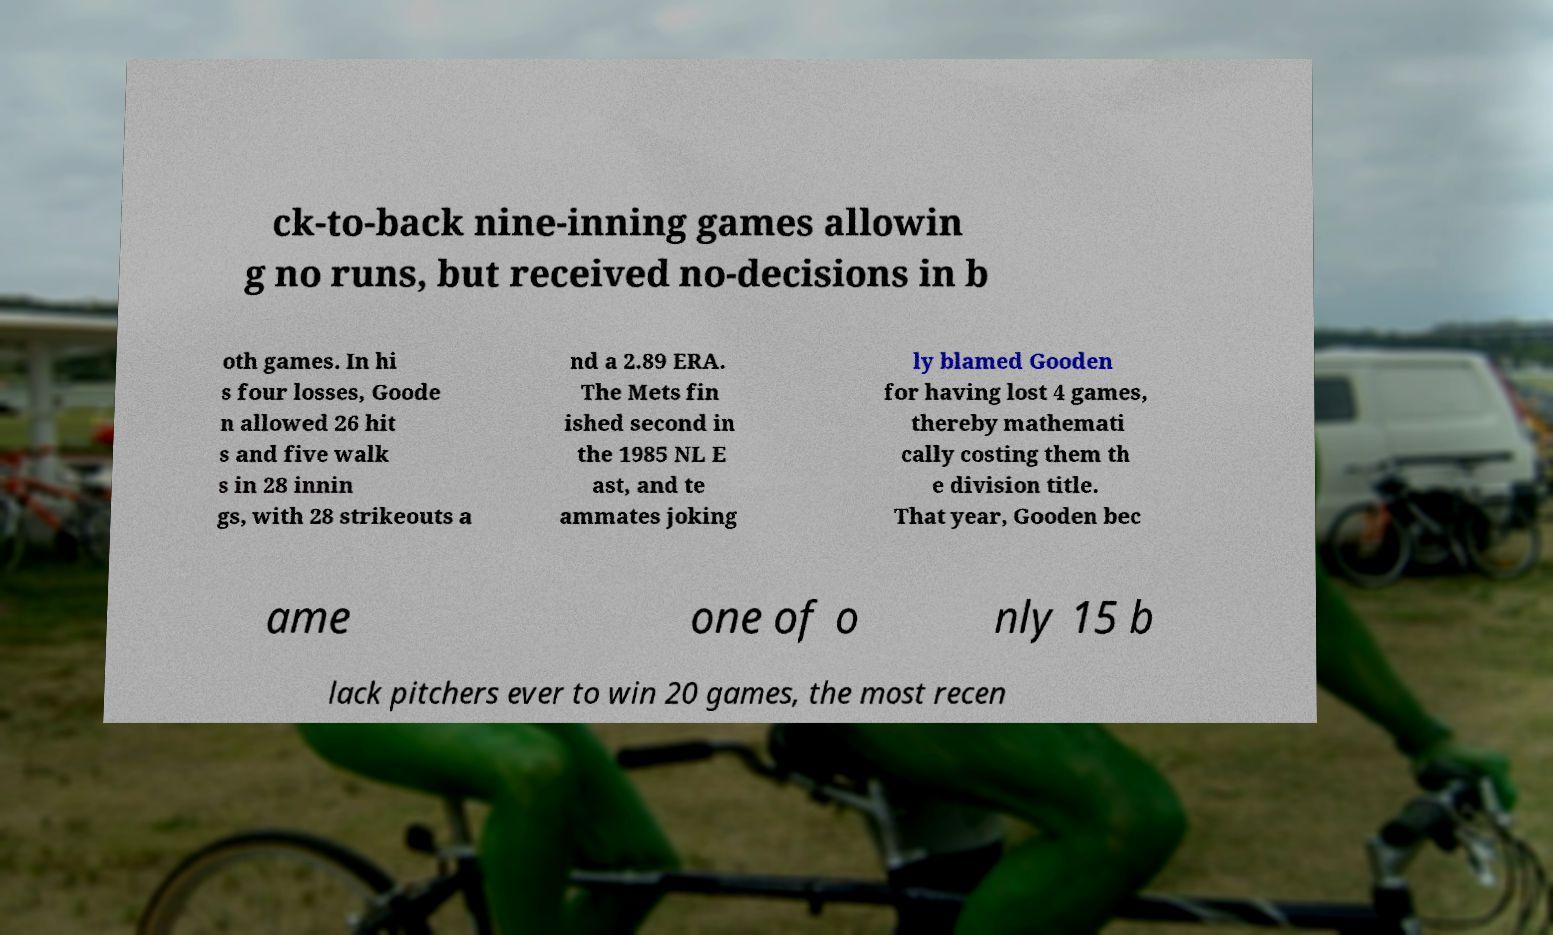Could you assist in decoding the text presented in this image and type it out clearly? ck-to-back nine-inning games allowin g no runs, but received no-decisions in b oth games. In hi s four losses, Goode n allowed 26 hit s and five walk s in 28 innin gs, with 28 strikeouts a nd a 2.89 ERA. The Mets fin ished second in the 1985 NL E ast, and te ammates joking ly blamed Gooden for having lost 4 games, thereby mathemati cally costing them th e division title. That year, Gooden bec ame one of o nly 15 b lack pitchers ever to win 20 games, the most recen 